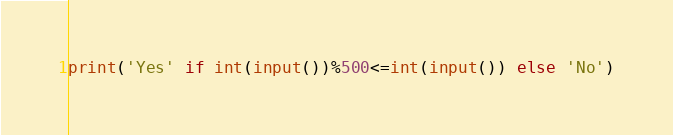<code> <loc_0><loc_0><loc_500><loc_500><_Python_>print('Yes' if int(input())%500<=int(input()) else 'No')</code> 